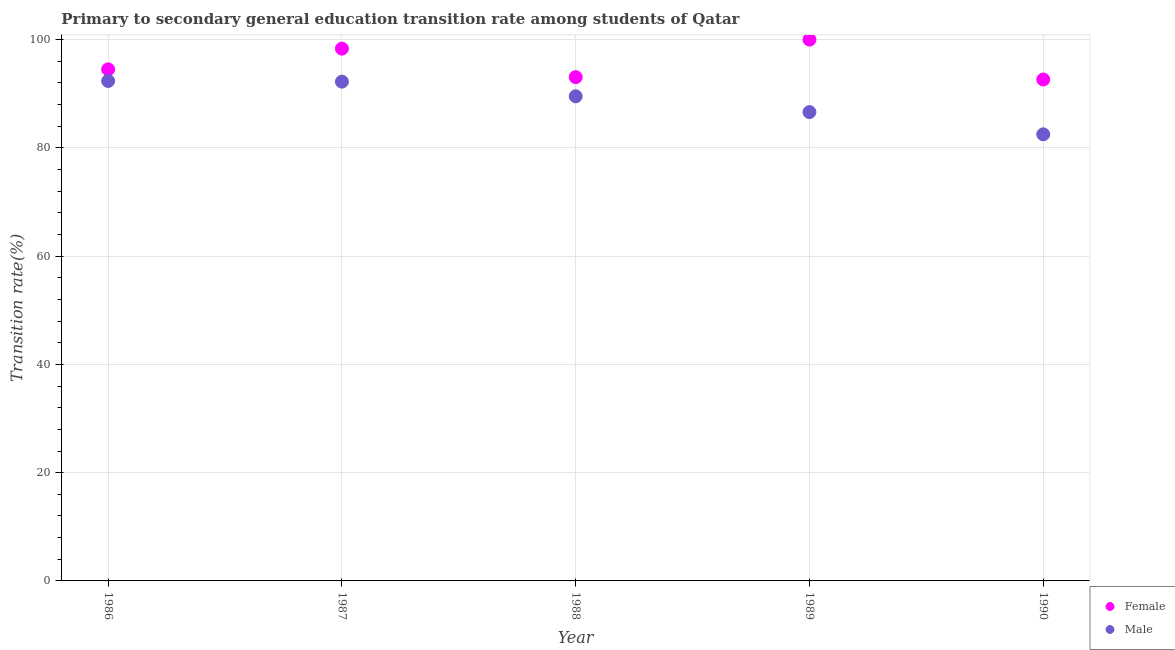How many different coloured dotlines are there?
Offer a terse response. 2. What is the transition rate among male students in 1988?
Your answer should be compact. 89.53. Across all years, what is the maximum transition rate among male students?
Offer a terse response. 92.36. Across all years, what is the minimum transition rate among female students?
Provide a short and direct response. 92.63. In which year was the transition rate among male students maximum?
Your answer should be very brief. 1986. What is the total transition rate among female students in the graph?
Make the answer very short. 478.54. What is the difference between the transition rate among male students in 1987 and that in 1988?
Keep it short and to the point. 2.7. What is the difference between the transition rate among male students in 1988 and the transition rate among female students in 1986?
Offer a very short reply. -4.98. What is the average transition rate among male students per year?
Make the answer very short. 88.65. In the year 1990, what is the difference between the transition rate among female students and transition rate among male students?
Offer a very short reply. 10.13. What is the ratio of the transition rate among female students in 1986 to that in 1988?
Provide a succinct answer. 1.02. Is the difference between the transition rate among female students in 1987 and 1990 greater than the difference between the transition rate among male students in 1987 and 1990?
Offer a very short reply. No. What is the difference between the highest and the second highest transition rate among female students?
Provide a succinct answer. 1.66. What is the difference between the highest and the lowest transition rate among female students?
Offer a terse response. 7.37. How many dotlines are there?
Give a very brief answer. 2. How many years are there in the graph?
Keep it short and to the point. 5. What is the difference between two consecutive major ticks on the Y-axis?
Keep it short and to the point. 20. Are the values on the major ticks of Y-axis written in scientific E-notation?
Your answer should be very brief. No. Does the graph contain any zero values?
Keep it short and to the point. No. Does the graph contain grids?
Give a very brief answer. Yes. Where does the legend appear in the graph?
Provide a short and direct response. Bottom right. What is the title of the graph?
Offer a very short reply. Primary to secondary general education transition rate among students of Qatar. Does "Private consumption" appear as one of the legend labels in the graph?
Your response must be concise. No. What is the label or title of the X-axis?
Provide a short and direct response. Year. What is the label or title of the Y-axis?
Your response must be concise. Transition rate(%). What is the Transition rate(%) in Female in 1986?
Offer a terse response. 94.51. What is the Transition rate(%) of Male in 1986?
Ensure brevity in your answer.  92.36. What is the Transition rate(%) of Female in 1987?
Provide a short and direct response. 98.34. What is the Transition rate(%) of Male in 1987?
Your answer should be very brief. 92.23. What is the Transition rate(%) of Female in 1988?
Keep it short and to the point. 93.06. What is the Transition rate(%) of Male in 1988?
Your answer should be compact. 89.53. What is the Transition rate(%) in Male in 1989?
Make the answer very short. 86.61. What is the Transition rate(%) of Female in 1990?
Provide a succinct answer. 92.63. What is the Transition rate(%) of Male in 1990?
Your answer should be compact. 82.5. Across all years, what is the maximum Transition rate(%) of Female?
Your answer should be very brief. 100. Across all years, what is the maximum Transition rate(%) of Male?
Your answer should be very brief. 92.36. Across all years, what is the minimum Transition rate(%) in Female?
Give a very brief answer. 92.63. Across all years, what is the minimum Transition rate(%) of Male?
Ensure brevity in your answer.  82.5. What is the total Transition rate(%) of Female in the graph?
Provide a succinct answer. 478.54. What is the total Transition rate(%) in Male in the graph?
Offer a very short reply. 443.24. What is the difference between the Transition rate(%) in Female in 1986 and that in 1987?
Your response must be concise. -3.83. What is the difference between the Transition rate(%) of Male in 1986 and that in 1987?
Give a very brief answer. 0.13. What is the difference between the Transition rate(%) in Female in 1986 and that in 1988?
Your response must be concise. 1.44. What is the difference between the Transition rate(%) of Male in 1986 and that in 1988?
Provide a short and direct response. 2.83. What is the difference between the Transition rate(%) in Female in 1986 and that in 1989?
Offer a terse response. -5.49. What is the difference between the Transition rate(%) of Male in 1986 and that in 1989?
Your answer should be compact. 5.75. What is the difference between the Transition rate(%) of Female in 1986 and that in 1990?
Offer a terse response. 1.88. What is the difference between the Transition rate(%) of Male in 1986 and that in 1990?
Give a very brief answer. 9.86. What is the difference between the Transition rate(%) of Female in 1987 and that in 1988?
Provide a succinct answer. 5.27. What is the difference between the Transition rate(%) in Male in 1987 and that in 1988?
Ensure brevity in your answer.  2.7. What is the difference between the Transition rate(%) in Female in 1987 and that in 1989?
Provide a short and direct response. -1.66. What is the difference between the Transition rate(%) in Male in 1987 and that in 1989?
Provide a succinct answer. 5.62. What is the difference between the Transition rate(%) of Female in 1987 and that in 1990?
Give a very brief answer. 5.71. What is the difference between the Transition rate(%) in Male in 1987 and that in 1990?
Offer a terse response. 9.73. What is the difference between the Transition rate(%) in Female in 1988 and that in 1989?
Keep it short and to the point. -6.94. What is the difference between the Transition rate(%) in Male in 1988 and that in 1989?
Give a very brief answer. 2.92. What is the difference between the Transition rate(%) in Female in 1988 and that in 1990?
Offer a very short reply. 0.43. What is the difference between the Transition rate(%) of Male in 1988 and that in 1990?
Keep it short and to the point. 7.03. What is the difference between the Transition rate(%) of Female in 1989 and that in 1990?
Your response must be concise. 7.37. What is the difference between the Transition rate(%) of Male in 1989 and that in 1990?
Keep it short and to the point. 4.11. What is the difference between the Transition rate(%) of Female in 1986 and the Transition rate(%) of Male in 1987?
Your response must be concise. 2.27. What is the difference between the Transition rate(%) of Female in 1986 and the Transition rate(%) of Male in 1988?
Make the answer very short. 4.98. What is the difference between the Transition rate(%) of Female in 1986 and the Transition rate(%) of Male in 1989?
Offer a terse response. 7.89. What is the difference between the Transition rate(%) of Female in 1986 and the Transition rate(%) of Male in 1990?
Your answer should be compact. 12. What is the difference between the Transition rate(%) of Female in 1987 and the Transition rate(%) of Male in 1988?
Provide a succinct answer. 8.81. What is the difference between the Transition rate(%) in Female in 1987 and the Transition rate(%) in Male in 1989?
Keep it short and to the point. 11.73. What is the difference between the Transition rate(%) of Female in 1987 and the Transition rate(%) of Male in 1990?
Offer a very short reply. 15.84. What is the difference between the Transition rate(%) of Female in 1988 and the Transition rate(%) of Male in 1989?
Your answer should be compact. 6.45. What is the difference between the Transition rate(%) in Female in 1988 and the Transition rate(%) in Male in 1990?
Provide a succinct answer. 10.56. What is the difference between the Transition rate(%) of Female in 1989 and the Transition rate(%) of Male in 1990?
Provide a short and direct response. 17.5. What is the average Transition rate(%) in Female per year?
Keep it short and to the point. 95.71. What is the average Transition rate(%) in Male per year?
Offer a very short reply. 88.65. In the year 1986, what is the difference between the Transition rate(%) of Female and Transition rate(%) of Male?
Keep it short and to the point. 2.15. In the year 1987, what is the difference between the Transition rate(%) of Female and Transition rate(%) of Male?
Give a very brief answer. 6.11. In the year 1988, what is the difference between the Transition rate(%) in Female and Transition rate(%) in Male?
Offer a terse response. 3.53. In the year 1989, what is the difference between the Transition rate(%) of Female and Transition rate(%) of Male?
Ensure brevity in your answer.  13.39. In the year 1990, what is the difference between the Transition rate(%) in Female and Transition rate(%) in Male?
Ensure brevity in your answer.  10.13. What is the ratio of the Transition rate(%) of Female in 1986 to that in 1988?
Ensure brevity in your answer.  1.02. What is the ratio of the Transition rate(%) in Male in 1986 to that in 1988?
Offer a terse response. 1.03. What is the ratio of the Transition rate(%) of Female in 1986 to that in 1989?
Keep it short and to the point. 0.95. What is the ratio of the Transition rate(%) of Male in 1986 to that in 1989?
Provide a succinct answer. 1.07. What is the ratio of the Transition rate(%) in Female in 1986 to that in 1990?
Provide a short and direct response. 1.02. What is the ratio of the Transition rate(%) of Male in 1986 to that in 1990?
Your answer should be compact. 1.12. What is the ratio of the Transition rate(%) of Female in 1987 to that in 1988?
Give a very brief answer. 1.06. What is the ratio of the Transition rate(%) in Male in 1987 to that in 1988?
Your answer should be compact. 1.03. What is the ratio of the Transition rate(%) in Female in 1987 to that in 1989?
Provide a succinct answer. 0.98. What is the ratio of the Transition rate(%) of Male in 1987 to that in 1989?
Keep it short and to the point. 1.06. What is the ratio of the Transition rate(%) in Female in 1987 to that in 1990?
Provide a succinct answer. 1.06. What is the ratio of the Transition rate(%) in Male in 1987 to that in 1990?
Your answer should be very brief. 1.12. What is the ratio of the Transition rate(%) in Female in 1988 to that in 1989?
Offer a terse response. 0.93. What is the ratio of the Transition rate(%) of Male in 1988 to that in 1989?
Your response must be concise. 1.03. What is the ratio of the Transition rate(%) of Male in 1988 to that in 1990?
Make the answer very short. 1.09. What is the ratio of the Transition rate(%) in Female in 1989 to that in 1990?
Provide a succinct answer. 1.08. What is the ratio of the Transition rate(%) in Male in 1989 to that in 1990?
Offer a terse response. 1.05. What is the difference between the highest and the second highest Transition rate(%) of Female?
Keep it short and to the point. 1.66. What is the difference between the highest and the second highest Transition rate(%) in Male?
Offer a terse response. 0.13. What is the difference between the highest and the lowest Transition rate(%) of Female?
Your answer should be very brief. 7.37. What is the difference between the highest and the lowest Transition rate(%) of Male?
Give a very brief answer. 9.86. 